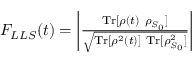Convert formula to latex. <formula><loc_0><loc_0><loc_500><loc_500>\begin{array} { r } { F _ { L L S } ( t ) = \left | \frac { T r [ \rho ( t ) \rho _ { S _ { 0 } } ] } { \sqrt { T r [ \rho ^ { 2 } ( t ) ] T r [ \rho _ { S _ { 0 } } ^ { 2 } ] } } \right | } \end{array}</formula> 